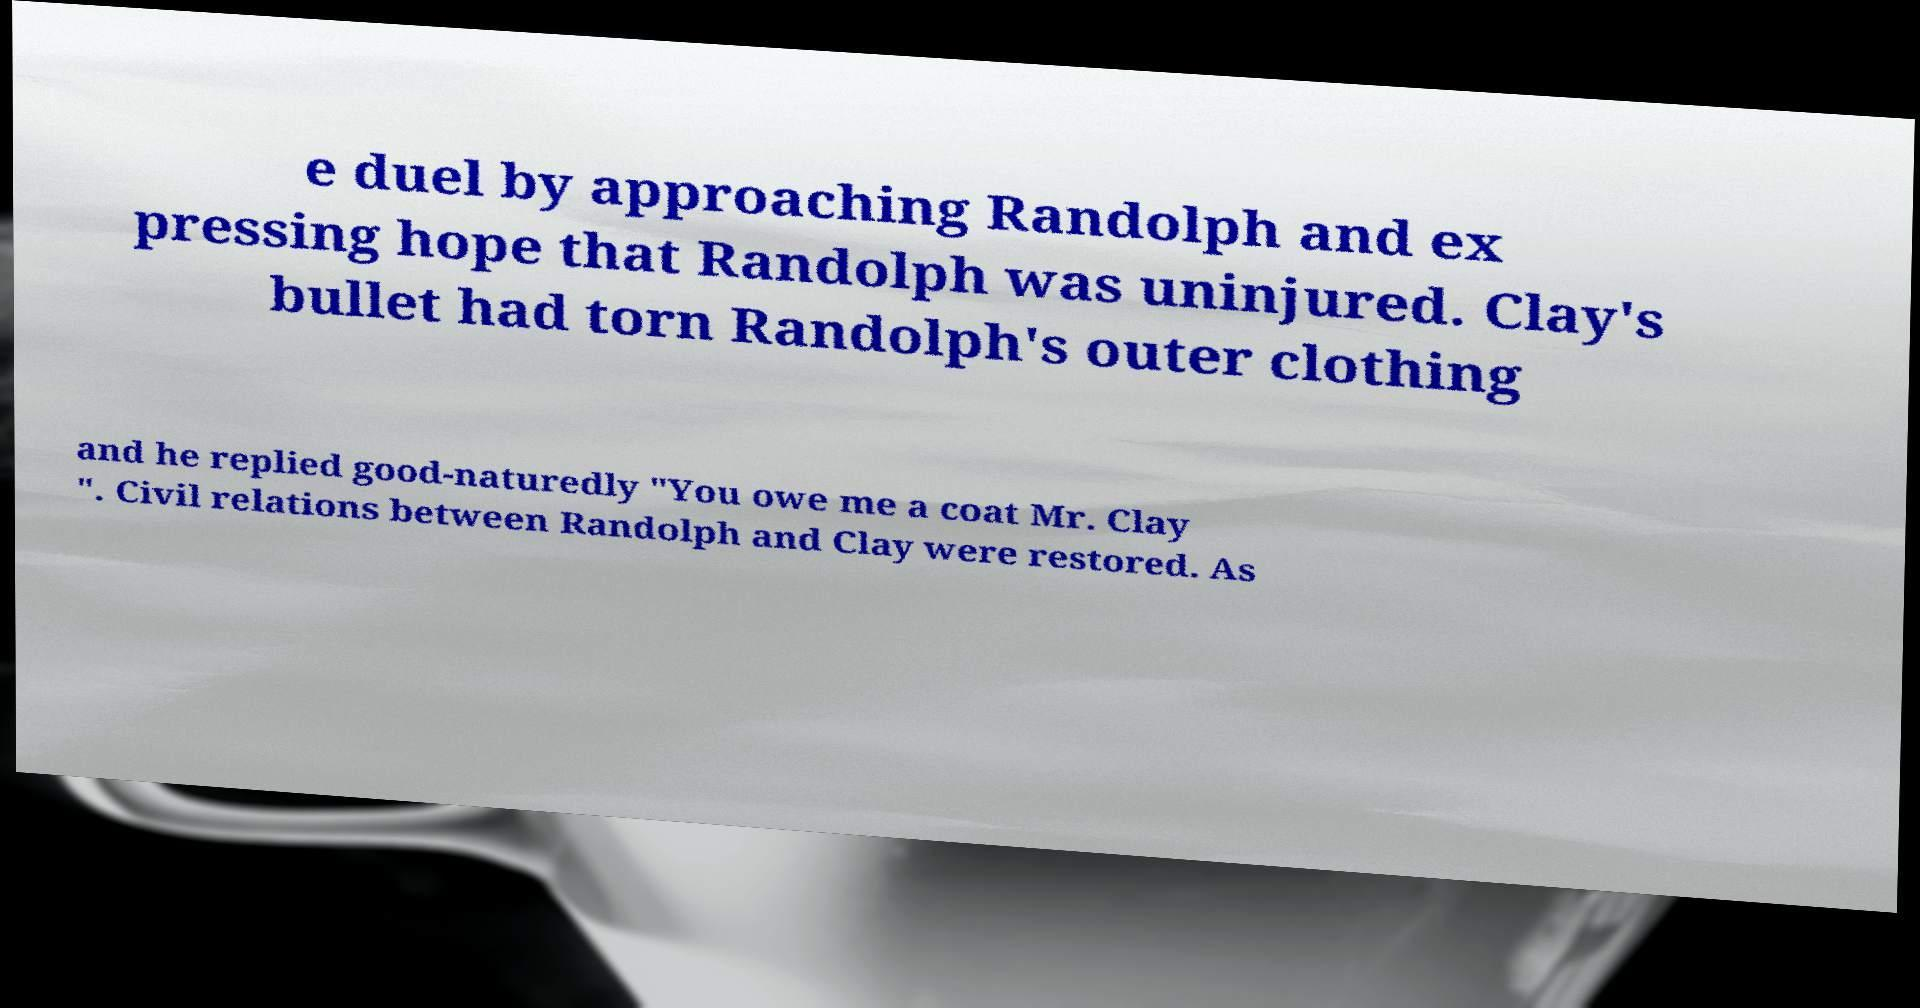What messages or text are displayed in this image? I need them in a readable, typed format. e duel by approaching Randolph and ex pressing hope that Randolph was uninjured. Clay's bullet had torn Randolph's outer clothing and he replied good-naturedly "You owe me a coat Mr. Clay ". Civil relations between Randolph and Clay were restored. As 